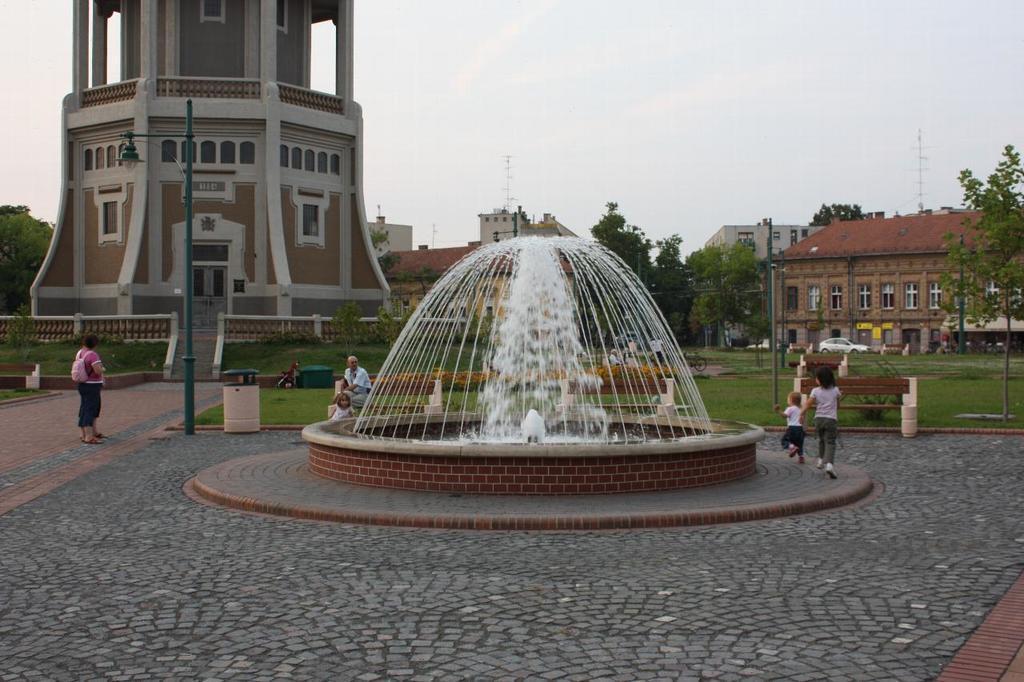Can you describe this image briefly? In front of the image there is a fountain. Around the fountain there are kids and adults. In the background of the image there are lamp posts, benches, trash cans, cars on the road, trees, towers and buildings.  